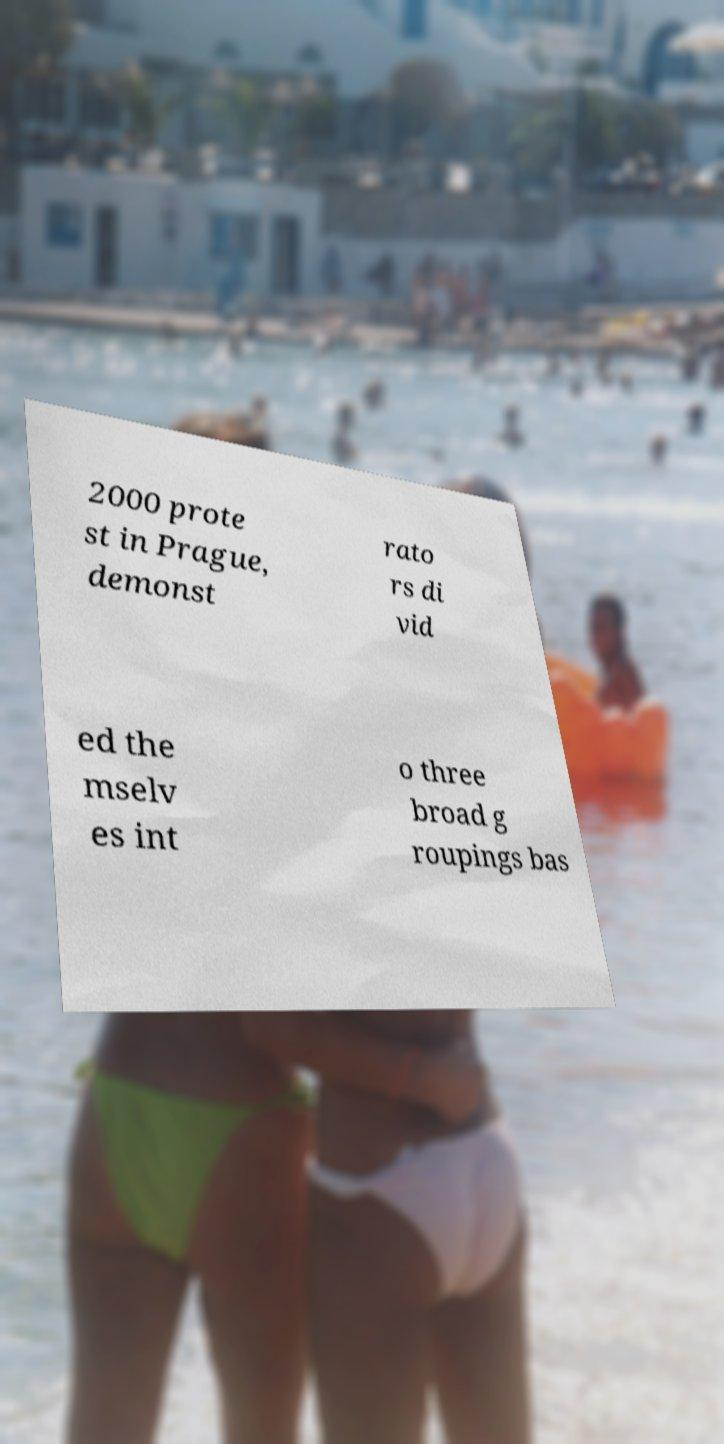Please read and relay the text visible in this image. What does it say? 2000 prote st in Prague, demonst rato rs di vid ed the mselv es int o three broad g roupings bas 